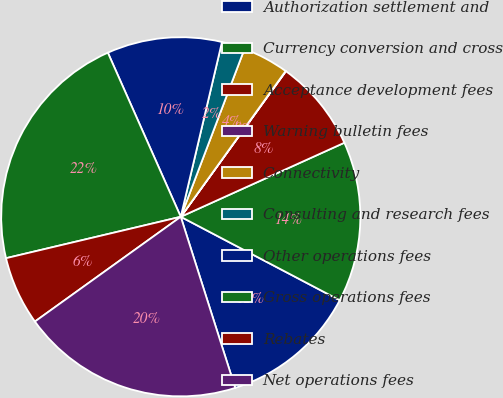Convert chart. <chart><loc_0><loc_0><loc_500><loc_500><pie_chart><fcel>Authorization settlement and<fcel>Currency conversion and cross<fcel>Acceptance development fees<fcel>Warning bulletin fees<fcel>Connectivity<fcel>Consulting and research fees<fcel>Other operations fees<fcel>Gross operations fees<fcel>Rebates<fcel>Net operations fees<nl><fcel>12.4%<fcel>14.46%<fcel>8.28%<fcel>0.03%<fcel>4.15%<fcel>2.09%<fcel>10.34%<fcel>22.05%<fcel>6.21%<fcel>19.99%<nl></chart> 